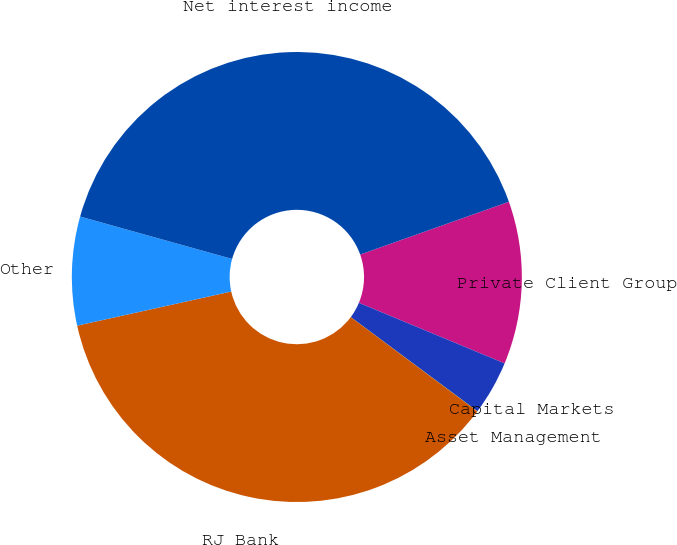<chart> <loc_0><loc_0><loc_500><loc_500><pie_chart><fcel>Private Client Group<fcel>Capital Markets<fcel>Asset Management<fcel>RJ Bank<fcel>Other<fcel>Net interest income<nl><fcel>11.7%<fcel>3.9%<fcel>0.01%<fcel>36.35%<fcel>7.8%<fcel>40.24%<nl></chart> 